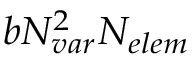<formula> <loc_0><loc_0><loc_500><loc_500>b { N _ { v a r } } ^ { 2 } { N _ { e l e m } }</formula> 